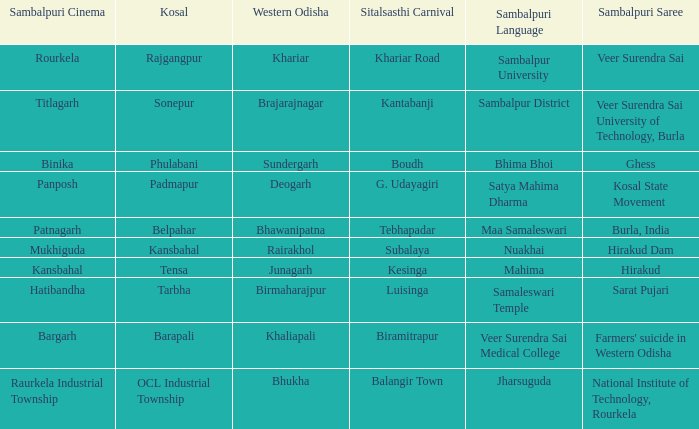What is the sambalpuri saree with a samaleswari temple as sambalpuri language? Sarat Pujari. 